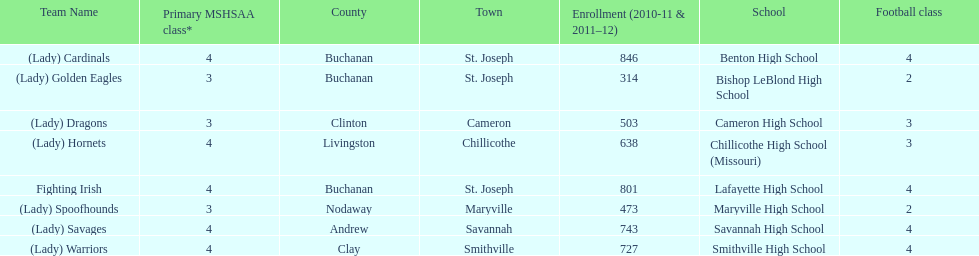How many teams are named after birds? 2. 